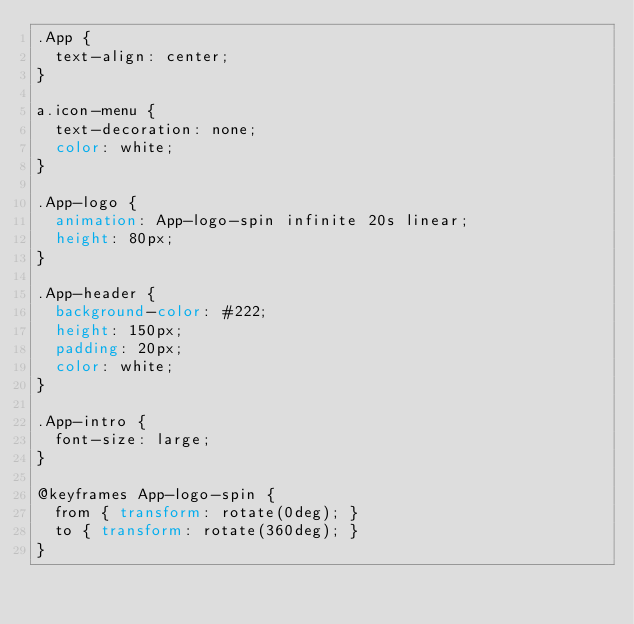<code> <loc_0><loc_0><loc_500><loc_500><_CSS_>.App {
  text-align: center;
}

a.icon-menu {
  text-decoration: none;
  color: white;
}

.App-logo {
  animation: App-logo-spin infinite 20s linear;
  height: 80px;
}

.App-header {
  background-color: #222;
  height: 150px;
  padding: 20px;
  color: white;
}

.App-intro {
  font-size: large;
}

@keyframes App-logo-spin {
  from { transform: rotate(0deg); }
  to { transform: rotate(360deg); }
}
</code> 